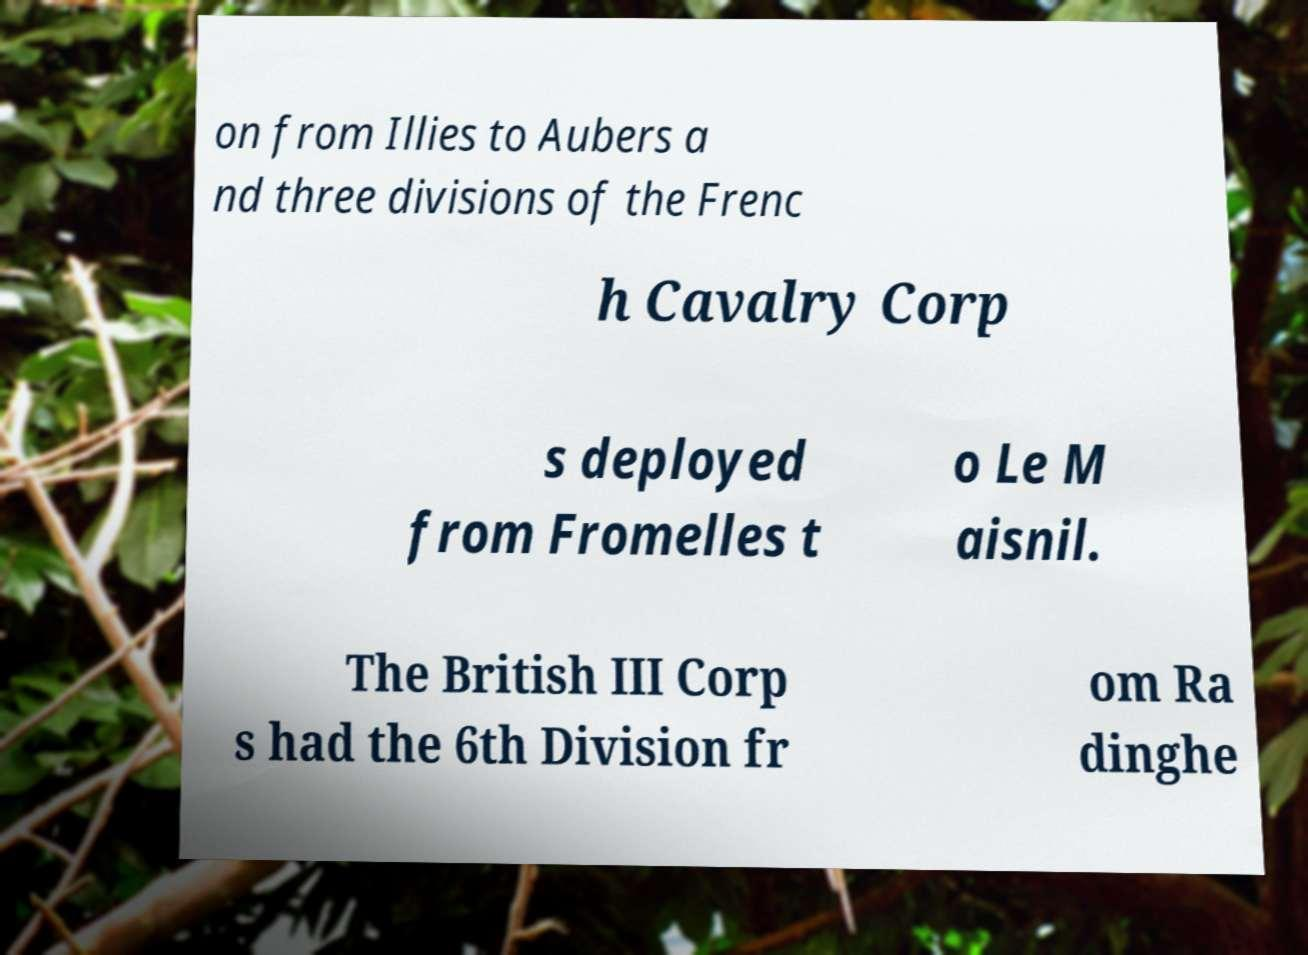Can you accurately transcribe the text from the provided image for me? on from Illies to Aubers a nd three divisions of the Frenc h Cavalry Corp s deployed from Fromelles t o Le M aisnil. The British III Corp s had the 6th Division fr om Ra dinghe 